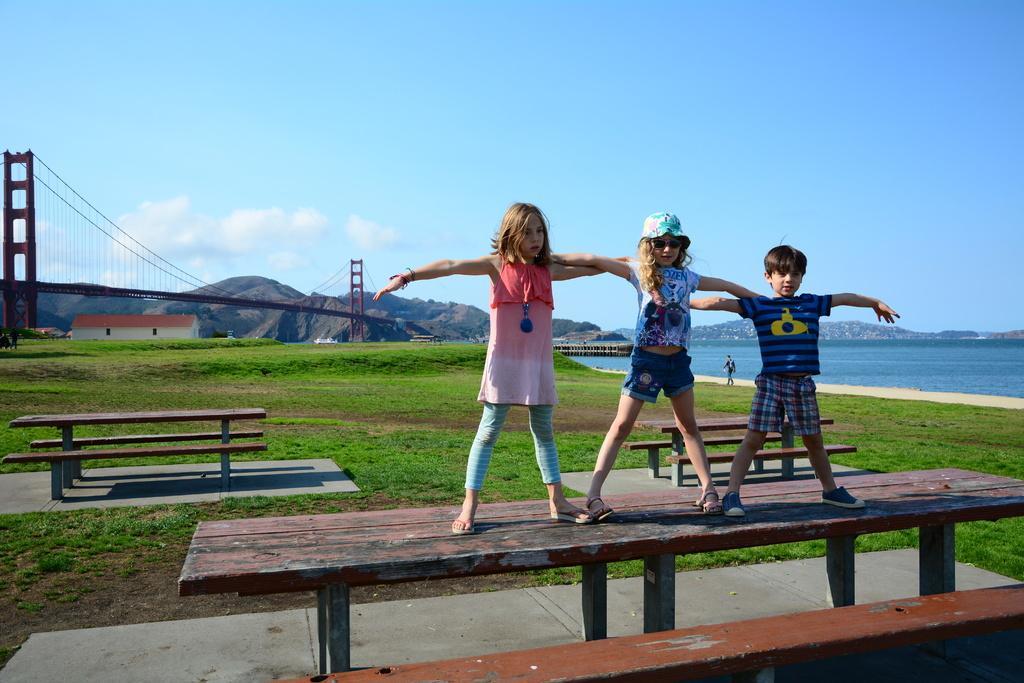In one or two sentences, can you explain what this image depicts? This picture is clicked outside. In the center we can see the children standing on the table. In the foreground we can see the benches and the tables and we can see the green grass, water body, bridge, ropes, houses and some other items. In the background we can see a person walking on the ground and we can see the sky, hills and some other items. 